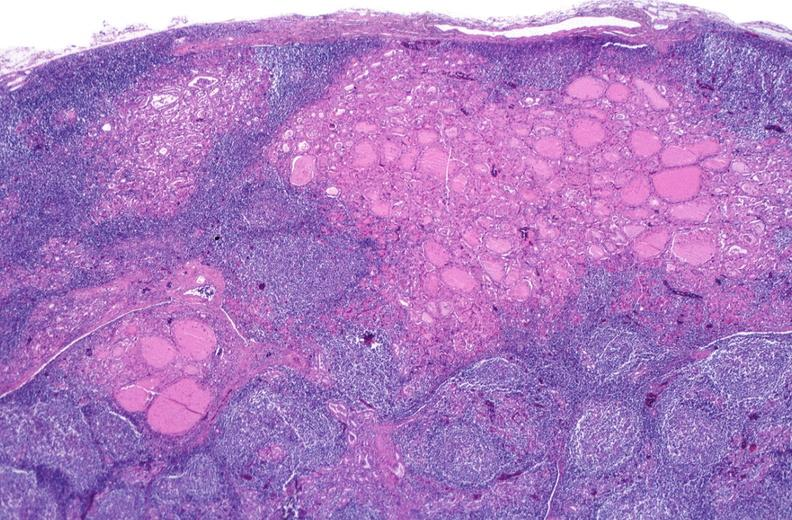does this section show hashimoto 's thyroiditis?
Answer the question using a single word or phrase. No 